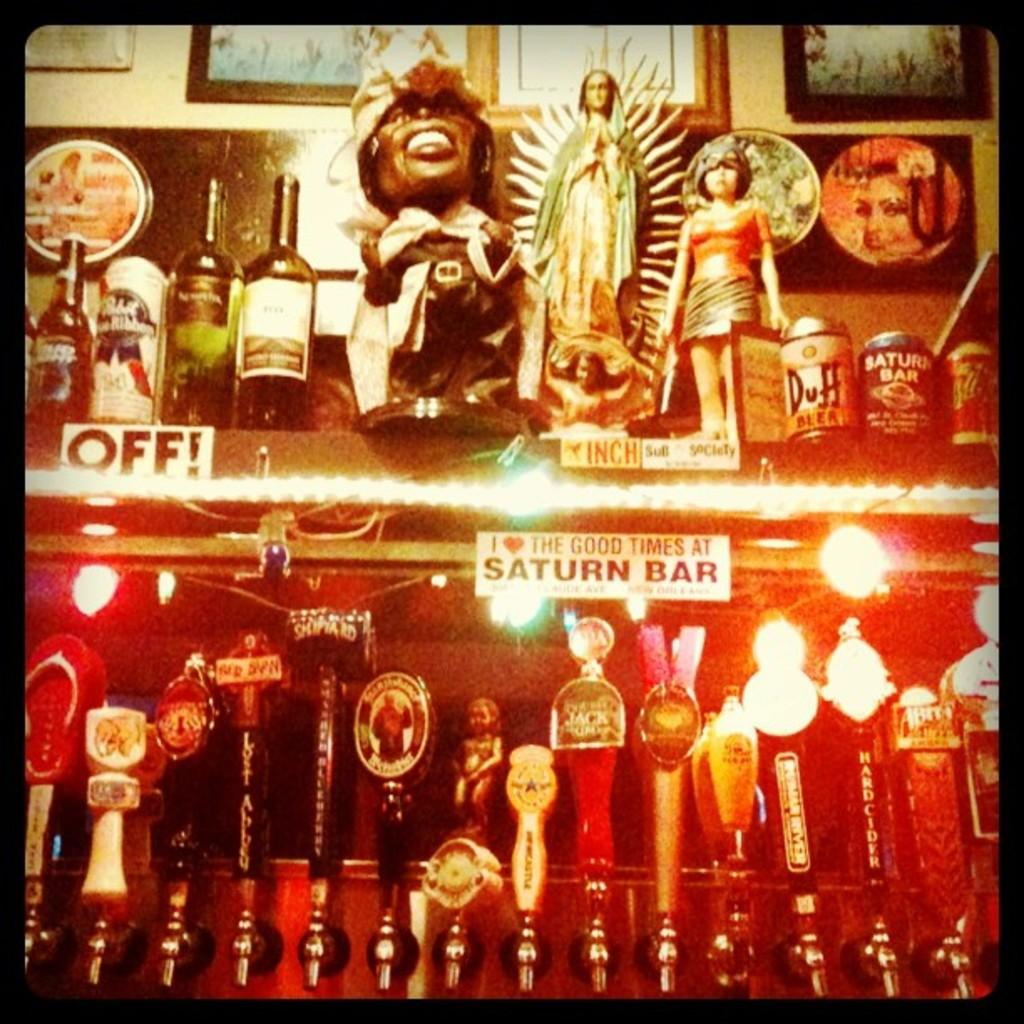<image>
Write a terse but informative summary of the picture. Store saying "OFF!" on the shelves and "I love the good times at Saturn Bar". 